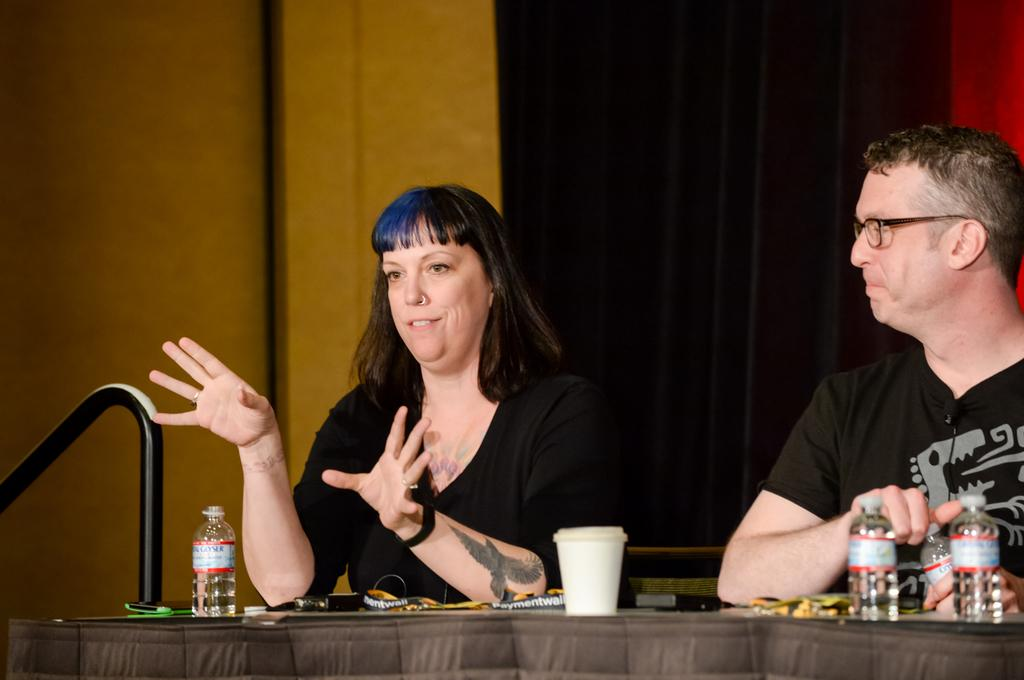How many people are sitting on the chair in the image? There are two persons sitting on a chair in the image. What is present on the chair with the persons? There is a table in the image. What can be seen on the table? There are bottles and a cup on the table. What can be seen in the background of the image? There is a curtain and a wall in the background. What type of wire is being used to create friction between the two persons sitting on the chair? There is no wire or friction present between the two persons sitting on the chair in the image. What color is the ink used to write on the cup in the image? There is no writing or ink present on the cup in the image. 